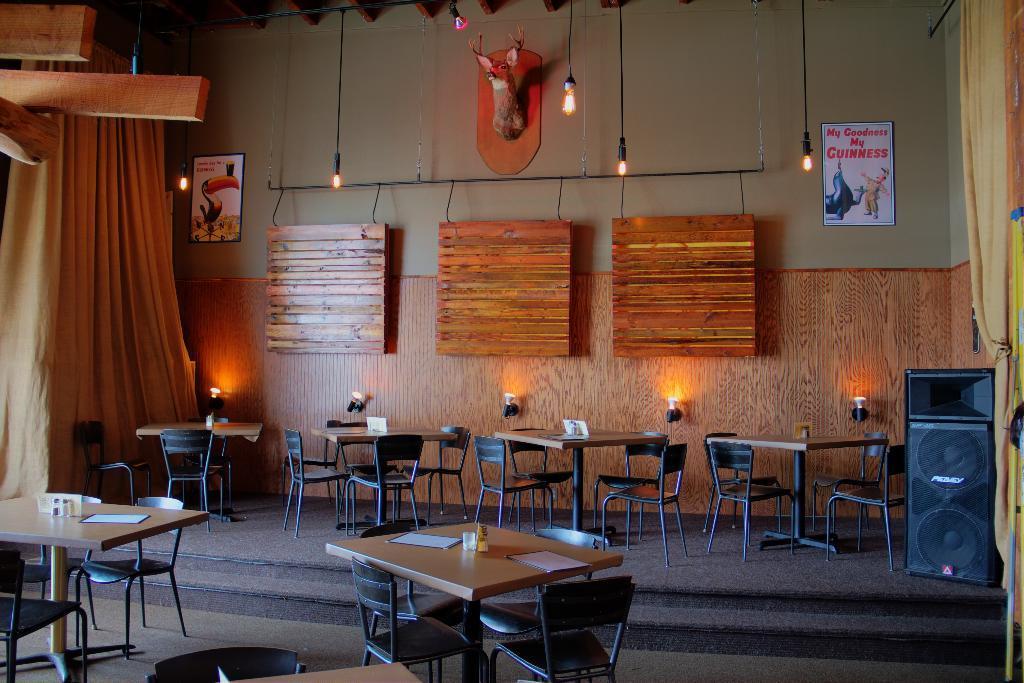Can you describe this image briefly? In this image there are many tables and chairs. On the tables there are papers and glasses. Behind the tables there's a wall. There are wooden boards hanging on the wall. Beside the boards there are papers with text sticked on the wall. Below the boards there are lights on the wall. At the top there is a sculpture on the wall. There are lights hanging to the ceiling. On the either sides of the image there are curtains. In the bottom right there is a speaker box on the floor. There is a carpet on the floor. 